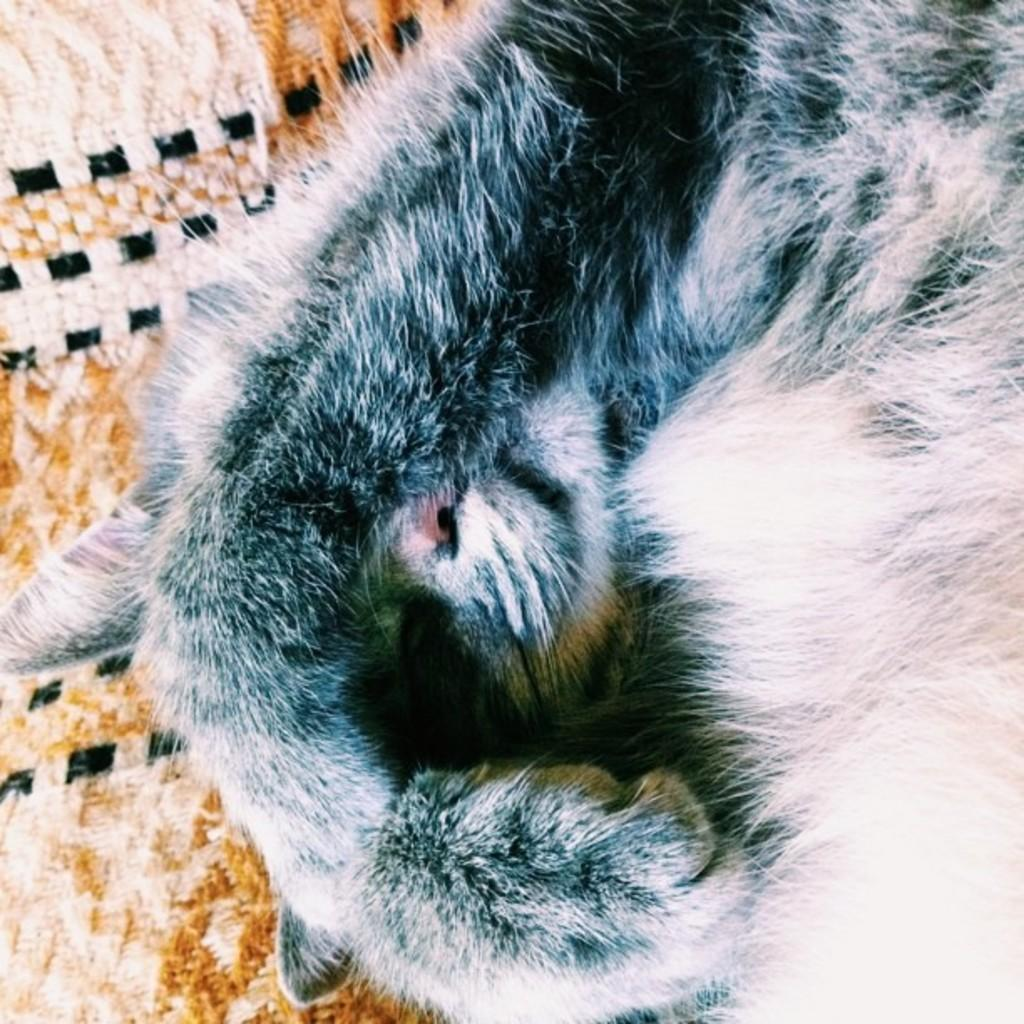What type of animal is in the image? There is a cat in the image. Can you describe any objects or features in the background of the image? There is an object in the background that looks like a cloth. What example of hearing can be seen in the image? There is no example of hearing present in the image; it features a cat and a cloth-like object in the background. Is there a rail visible in the image? There is no rail present in the image. 